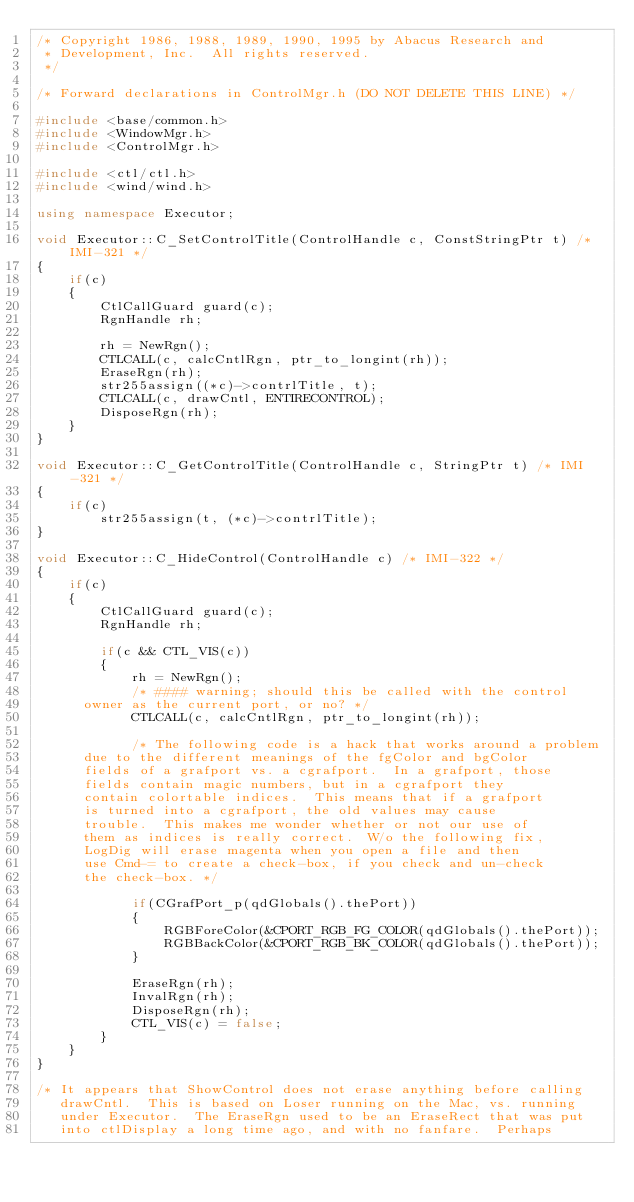Convert code to text. <code><loc_0><loc_0><loc_500><loc_500><_C++_>/* Copyright 1986, 1988, 1989, 1990, 1995 by Abacus Research and
 * Development, Inc.  All rights reserved.
 */

/* Forward declarations in ControlMgr.h (DO NOT DELETE THIS LINE) */

#include <base/common.h>
#include <WindowMgr.h>
#include <ControlMgr.h>

#include <ctl/ctl.h>
#include <wind/wind.h>

using namespace Executor;

void Executor::C_SetControlTitle(ControlHandle c, ConstStringPtr t) /* IMI-321 */
{
    if(c)
    {
        CtlCallGuard guard(c);
        RgnHandle rh;

        rh = NewRgn();
        CTLCALL(c, calcCntlRgn, ptr_to_longint(rh));
        EraseRgn(rh);
        str255assign((*c)->contrlTitle, t);
        CTLCALL(c, drawCntl, ENTIRECONTROL);
        DisposeRgn(rh);
    }
}

void Executor::C_GetControlTitle(ControlHandle c, StringPtr t) /* IMI-321 */
{
    if(c)
        str255assign(t, (*c)->contrlTitle);
}

void Executor::C_HideControl(ControlHandle c) /* IMI-322 */
{
    if(c)
    {
        CtlCallGuard guard(c);
        RgnHandle rh;

        if(c && CTL_VIS(c))
        {
            rh = NewRgn();
            /* #### warning; should this be called with the control
		  owner as the current port, or no? */
            CTLCALL(c, calcCntlRgn, ptr_to_longint(rh));

            /* The following code is a hack that works around a problem
		  due to the different meanings of the fgColor and bgColor
		  fields of a grafport vs. a cgrafport.  In a grafport, those
		  fields contain magic numbers, but in a cgrafport they
		  contain colortable indices.  This means that if a grafport
		  is turned into a cgrafport, the old values may cause
		  trouble.  This makes me wonder whether or not our use of
		  them as indices is really correct.  W/o the following fix,
		  LogDig will erase magenta when you open a file and then
		  use Cmd-= to create a check-box, if you check and un-check
		  the check-box. */

            if(CGrafPort_p(qdGlobals().thePort))
            {
                RGBForeColor(&CPORT_RGB_FG_COLOR(qdGlobals().thePort));
                RGBBackColor(&CPORT_RGB_BK_COLOR(qdGlobals().thePort));
            }

            EraseRgn(rh);
            InvalRgn(rh);
            DisposeRgn(rh);
            CTL_VIS(c) = false;
        }
    }
}

/* It appears that ShowControl does not erase anything before calling
   drawCntl.  This is based on Loser running on the Mac, vs. running
   under Executor.  The EraseRgn used to be an EraseRect that was put
   into ctlDisplay a long time ago, and with no fanfare.  Perhaps</code> 